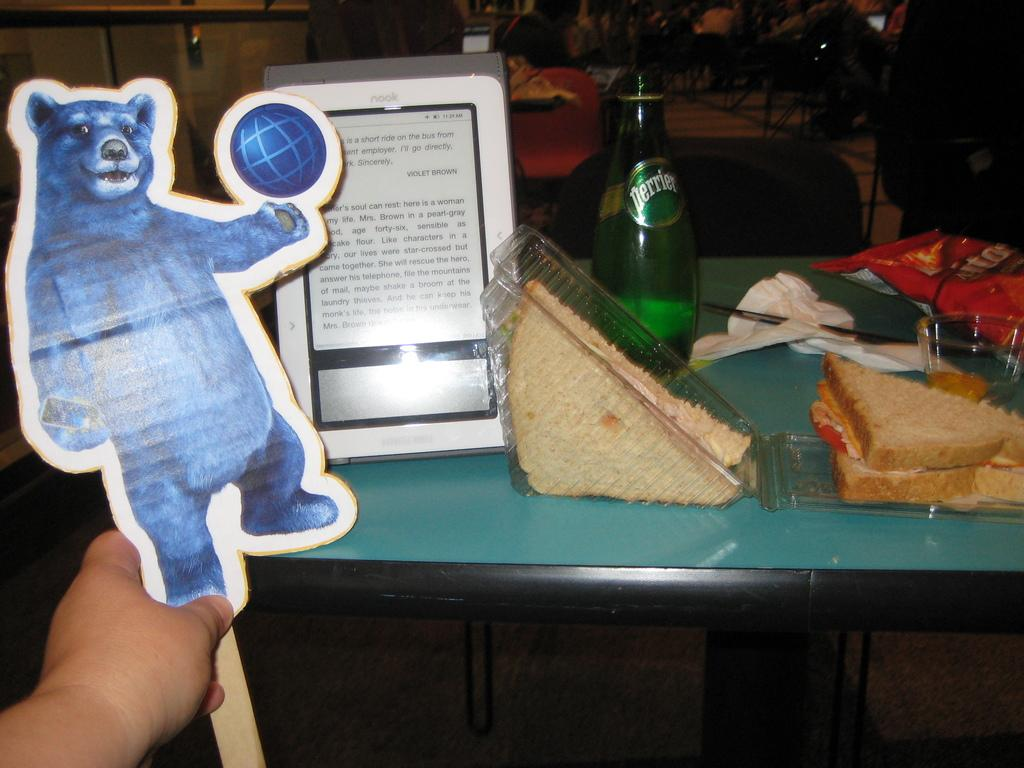<image>
Present a compact description of the photo's key features. A table with food and a bottle of Perrier water. 